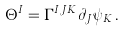<formula> <loc_0><loc_0><loc_500><loc_500>\Theta ^ { I } = \Gamma ^ { I J K } \partial _ { J } \psi _ { K } \, .</formula> 